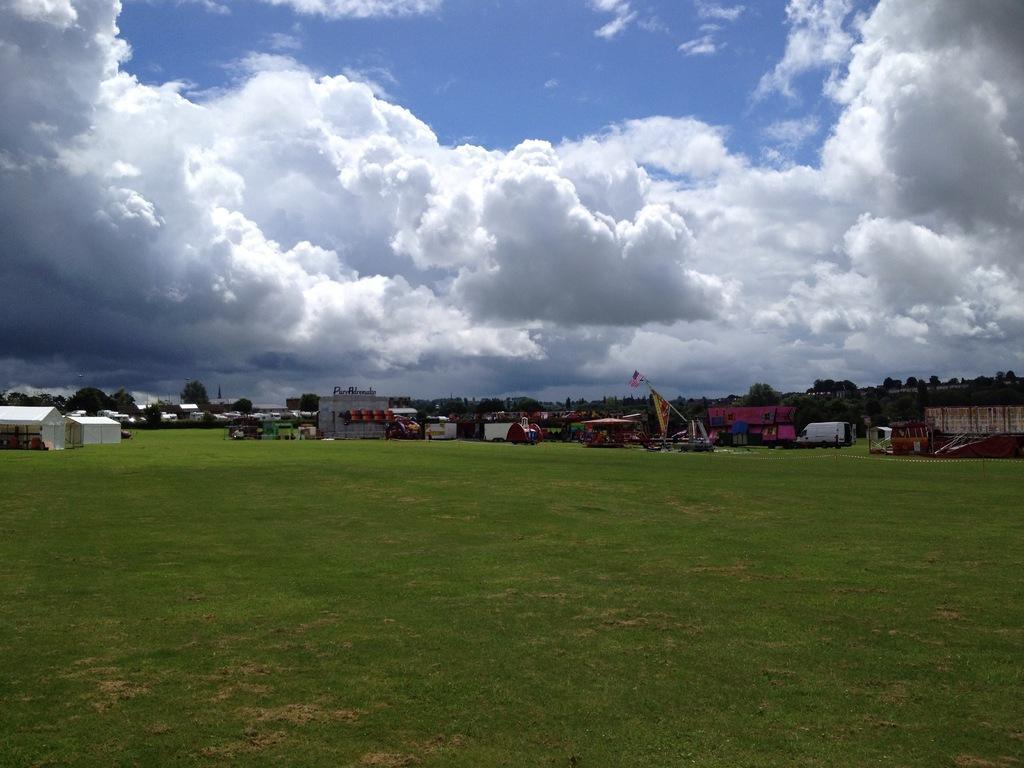Could you give a brief overview of what you see in this image? In this picture we can see pens, buildings, vehicles, shed and other objects. In the background we can see the many trees. At the top we can see sky and clouds. At the bottom we can see green grass and open area. 